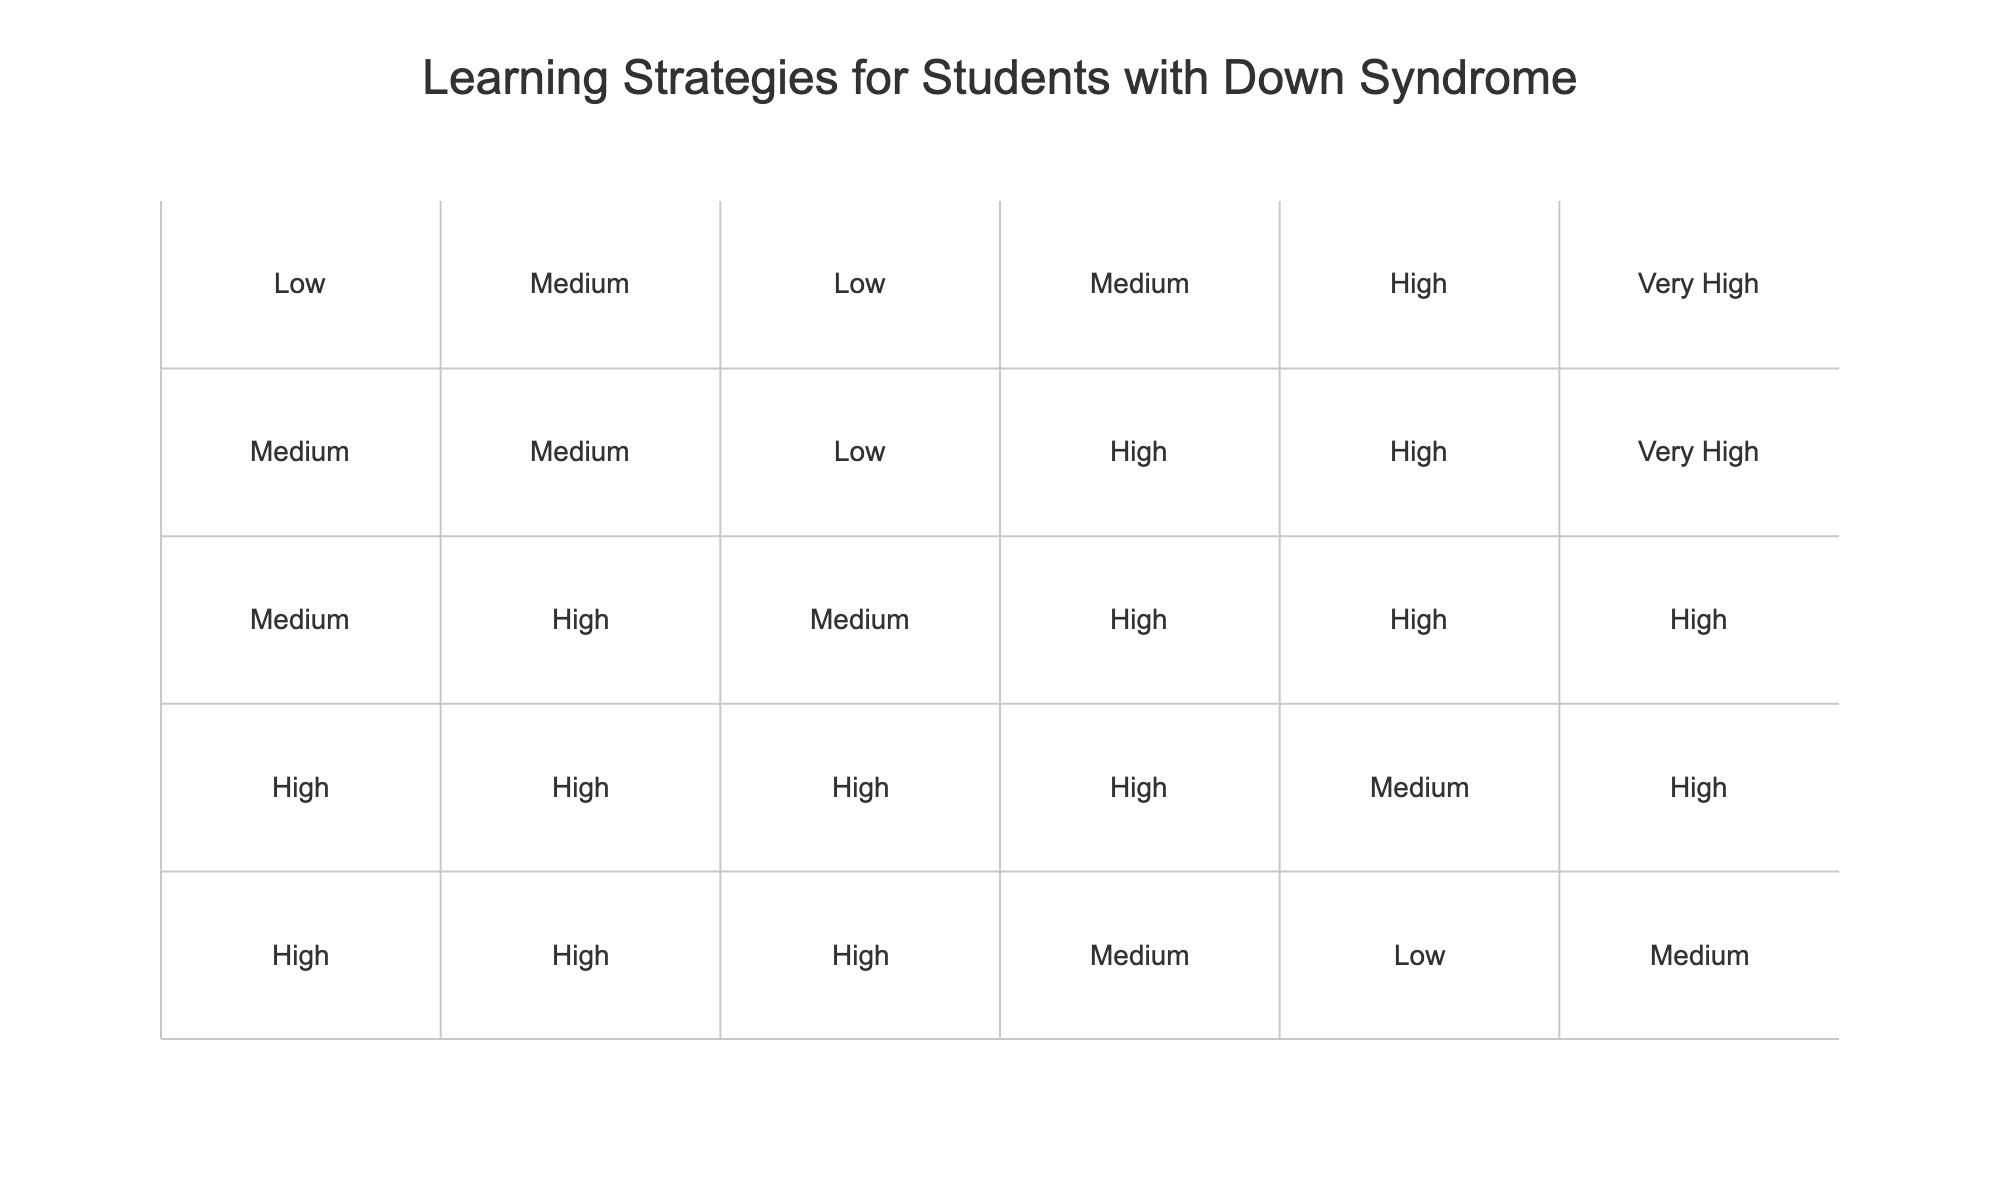What learning strategy has the highest usage in early childhood? In the early childhood age group (3-5 years), the strategy with the highest usage is Visual Aids, as it is marked as "High".
Answer: Visual Aids Which strategy sees a decline from early childhood to adult age groups? Looking at the data, Visual Aids shows a decline from "High" in early childhood to "Low" in adults (22+), indicating a decreasing emphasis on this strategy as age increases.
Answer: Visual Aids Is there any learning strategy that remains consistently high across all age groups? By analyzing the table, no single strategy is listed as "High" across all age groups. Each one varies significantly, showing different patterns of emphasis as students grow older.
Answer: No What is the average rating for Practical Life Skills across all age groups? The ratings for Practical Life Skills are Medium (3), High (4), High (4), Very High (5), and Very High (5) for each age group respectively. Adding these values gives 3 + 4 + 4 + 5 + 5 = 21. Dividing by the number of age groups (5), the average is 21/5 = 4.2, which corresponds to between High and Very High.
Answer: 4.2 Which age group has the lowest rating for Assistive Technology? From the table, the Adult (22+) age group has the lowest rating for Assistive Technology, marked as "Medium".
Answer: Adult (22+) Does Peer-Assisted Learning increase or decrease from childhood to young adulthood? Looking closely, Peer-Assisted Learning shows an increase from Medium in early childhood to High in elementary, and it remains High through adolescence and young adulthood. Therefore, it increases initially and then maintains that level.
Answer: Increase Identify one learning strategy that is rated Very High for young adults. In the table, Assistive Technology is rated Very High for the young adult age group (18-21).
Answer: Assistive Technology Which age group benefits the most from Repetition as a learning strategy? The data shows that Repetition is rated High for early childhood and elementary, but it is also High for adolescents. However, there is no age group where it is rated Higher than High. Thus, there is no clear "most" benefiting group specifically for Repetition.
Answer: No clear "most" Are there any age groups where Multisensory Approach has the same rating? In the table, only the young adult (18-21) and adult (22+) age groups have the same rating of Low for Multisensory Approach.
Answer: Yes, Young Adult and Adult What is the trend of Assistive Technology ratings from early childhood to adulthood? The ratings for Assistive Technology start from Low in early childhood, rise to Medium in elementary and adolescents, and then reach High in young adults and remain High in adults. This indicates a general upward trend in its usage over the age groups.
Answer: Upward trend 